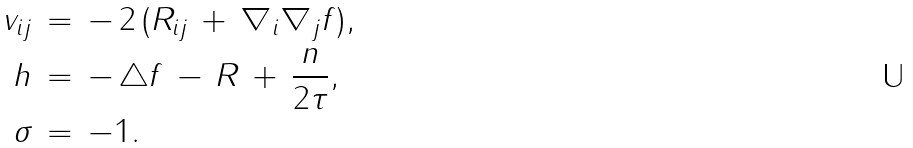<formula> <loc_0><loc_0><loc_500><loc_500>v _ { i j } \, & = \, - \, 2 \, ( R _ { i j } \, + \, \nabla _ { i } \nabla _ { j } f ) , \\ h \, & = \, - \, \triangle f \, - \, R \, + \, \frac { n } { 2 \tau } , \\ \sigma \, & = \, - 1 .</formula> 